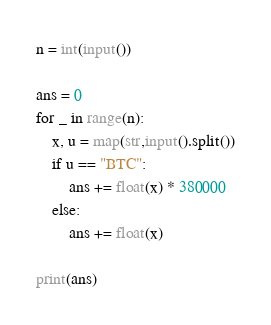Convert code to text. <code><loc_0><loc_0><loc_500><loc_500><_Python_>n = int(input())

ans = 0
for _ in range(n):
    x, u = map(str,input().split())
    if u == "BTC":
        ans += float(x) * 380000
    else:
        ans += float(x)
        
print(ans)</code> 